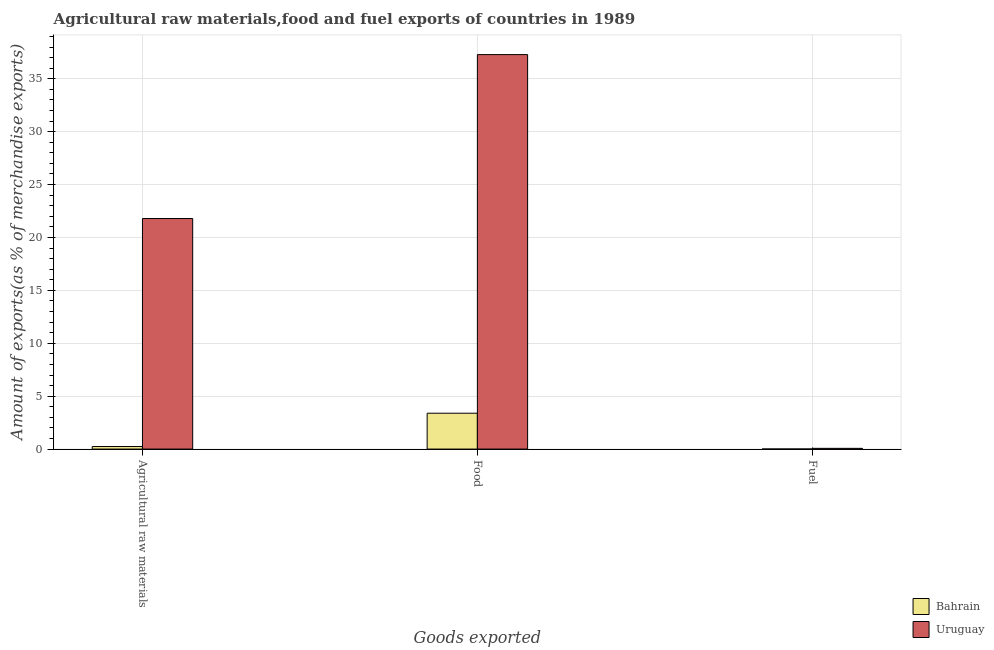How many groups of bars are there?
Offer a terse response. 3. Are the number of bars per tick equal to the number of legend labels?
Make the answer very short. Yes. Are the number of bars on each tick of the X-axis equal?
Offer a very short reply. Yes. How many bars are there on the 2nd tick from the left?
Provide a succinct answer. 2. How many bars are there on the 1st tick from the right?
Your answer should be very brief. 2. What is the label of the 1st group of bars from the left?
Make the answer very short. Agricultural raw materials. What is the percentage of food exports in Uruguay?
Keep it short and to the point. 37.28. Across all countries, what is the maximum percentage of raw materials exports?
Keep it short and to the point. 21.79. Across all countries, what is the minimum percentage of food exports?
Your response must be concise. 3.39. In which country was the percentage of fuel exports maximum?
Your response must be concise. Uruguay. In which country was the percentage of fuel exports minimum?
Your response must be concise. Bahrain. What is the total percentage of fuel exports in the graph?
Give a very brief answer. 0.07. What is the difference between the percentage of fuel exports in Bahrain and that in Uruguay?
Your response must be concise. -0.06. What is the difference between the percentage of raw materials exports in Uruguay and the percentage of food exports in Bahrain?
Your answer should be compact. 18.4. What is the average percentage of fuel exports per country?
Ensure brevity in your answer.  0.04. What is the difference between the percentage of food exports and percentage of raw materials exports in Bahrain?
Provide a succinct answer. 3.15. What is the ratio of the percentage of food exports in Bahrain to that in Uruguay?
Offer a very short reply. 0.09. Is the difference between the percentage of food exports in Uruguay and Bahrain greater than the difference between the percentage of fuel exports in Uruguay and Bahrain?
Make the answer very short. Yes. What is the difference between the highest and the second highest percentage of fuel exports?
Your response must be concise. 0.06. What is the difference between the highest and the lowest percentage of raw materials exports?
Ensure brevity in your answer.  21.55. What does the 1st bar from the left in Agricultural raw materials represents?
Ensure brevity in your answer.  Bahrain. What does the 1st bar from the right in Agricultural raw materials represents?
Keep it short and to the point. Uruguay. Is it the case that in every country, the sum of the percentage of raw materials exports and percentage of food exports is greater than the percentage of fuel exports?
Give a very brief answer. Yes. What is the difference between two consecutive major ticks on the Y-axis?
Provide a short and direct response. 5. Does the graph contain grids?
Your answer should be very brief. Yes. Where does the legend appear in the graph?
Provide a succinct answer. Bottom right. How are the legend labels stacked?
Provide a short and direct response. Vertical. What is the title of the graph?
Your answer should be very brief. Agricultural raw materials,food and fuel exports of countries in 1989. What is the label or title of the X-axis?
Your response must be concise. Goods exported. What is the label or title of the Y-axis?
Provide a short and direct response. Amount of exports(as % of merchandise exports). What is the Amount of exports(as % of merchandise exports) of Bahrain in Agricultural raw materials?
Your answer should be very brief. 0.24. What is the Amount of exports(as % of merchandise exports) in Uruguay in Agricultural raw materials?
Make the answer very short. 21.79. What is the Amount of exports(as % of merchandise exports) in Bahrain in Food?
Offer a terse response. 3.39. What is the Amount of exports(as % of merchandise exports) in Uruguay in Food?
Keep it short and to the point. 37.28. What is the Amount of exports(as % of merchandise exports) in Bahrain in Fuel?
Keep it short and to the point. 0. What is the Amount of exports(as % of merchandise exports) of Uruguay in Fuel?
Offer a very short reply. 0.07. Across all Goods exported, what is the maximum Amount of exports(as % of merchandise exports) of Bahrain?
Your answer should be very brief. 3.39. Across all Goods exported, what is the maximum Amount of exports(as % of merchandise exports) of Uruguay?
Provide a succinct answer. 37.28. Across all Goods exported, what is the minimum Amount of exports(as % of merchandise exports) of Bahrain?
Offer a terse response. 0. Across all Goods exported, what is the minimum Amount of exports(as % of merchandise exports) in Uruguay?
Provide a short and direct response. 0.07. What is the total Amount of exports(as % of merchandise exports) in Bahrain in the graph?
Your answer should be very brief. 3.64. What is the total Amount of exports(as % of merchandise exports) in Uruguay in the graph?
Keep it short and to the point. 59.14. What is the difference between the Amount of exports(as % of merchandise exports) in Bahrain in Agricultural raw materials and that in Food?
Provide a short and direct response. -3.15. What is the difference between the Amount of exports(as % of merchandise exports) in Uruguay in Agricultural raw materials and that in Food?
Provide a succinct answer. -15.49. What is the difference between the Amount of exports(as % of merchandise exports) of Bahrain in Agricultural raw materials and that in Fuel?
Provide a short and direct response. 0.24. What is the difference between the Amount of exports(as % of merchandise exports) in Uruguay in Agricultural raw materials and that in Fuel?
Offer a very short reply. 21.72. What is the difference between the Amount of exports(as % of merchandise exports) in Bahrain in Food and that in Fuel?
Provide a succinct answer. 3.39. What is the difference between the Amount of exports(as % of merchandise exports) of Uruguay in Food and that in Fuel?
Give a very brief answer. 37.21. What is the difference between the Amount of exports(as % of merchandise exports) of Bahrain in Agricultural raw materials and the Amount of exports(as % of merchandise exports) of Uruguay in Food?
Provide a short and direct response. -37.04. What is the difference between the Amount of exports(as % of merchandise exports) in Bahrain in Agricultural raw materials and the Amount of exports(as % of merchandise exports) in Uruguay in Fuel?
Offer a very short reply. 0.17. What is the difference between the Amount of exports(as % of merchandise exports) of Bahrain in Food and the Amount of exports(as % of merchandise exports) of Uruguay in Fuel?
Offer a very short reply. 3.32. What is the average Amount of exports(as % of merchandise exports) of Bahrain per Goods exported?
Make the answer very short. 1.21. What is the average Amount of exports(as % of merchandise exports) in Uruguay per Goods exported?
Provide a succinct answer. 19.71. What is the difference between the Amount of exports(as % of merchandise exports) of Bahrain and Amount of exports(as % of merchandise exports) of Uruguay in Agricultural raw materials?
Ensure brevity in your answer.  -21.55. What is the difference between the Amount of exports(as % of merchandise exports) in Bahrain and Amount of exports(as % of merchandise exports) in Uruguay in Food?
Ensure brevity in your answer.  -33.89. What is the difference between the Amount of exports(as % of merchandise exports) of Bahrain and Amount of exports(as % of merchandise exports) of Uruguay in Fuel?
Your answer should be very brief. -0.06. What is the ratio of the Amount of exports(as % of merchandise exports) in Bahrain in Agricultural raw materials to that in Food?
Make the answer very short. 0.07. What is the ratio of the Amount of exports(as % of merchandise exports) in Uruguay in Agricultural raw materials to that in Food?
Make the answer very short. 0.58. What is the ratio of the Amount of exports(as % of merchandise exports) of Bahrain in Agricultural raw materials to that in Fuel?
Ensure brevity in your answer.  56.05. What is the ratio of the Amount of exports(as % of merchandise exports) of Uruguay in Agricultural raw materials to that in Fuel?
Offer a terse response. 318.25. What is the ratio of the Amount of exports(as % of merchandise exports) of Bahrain in Food to that in Fuel?
Offer a very short reply. 787.43. What is the ratio of the Amount of exports(as % of merchandise exports) of Uruguay in Food to that in Fuel?
Provide a succinct answer. 544.53. What is the difference between the highest and the second highest Amount of exports(as % of merchandise exports) in Bahrain?
Offer a very short reply. 3.15. What is the difference between the highest and the second highest Amount of exports(as % of merchandise exports) of Uruguay?
Your answer should be compact. 15.49. What is the difference between the highest and the lowest Amount of exports(as % of merchandise exports) of Bahrain?
Provide a succinct answer. 3.39. What is the difference between the highest and the lowest Amount of exports(as % of merchandise exports) in Uruguay?
Ensure brevity in your answer.  37.21. 